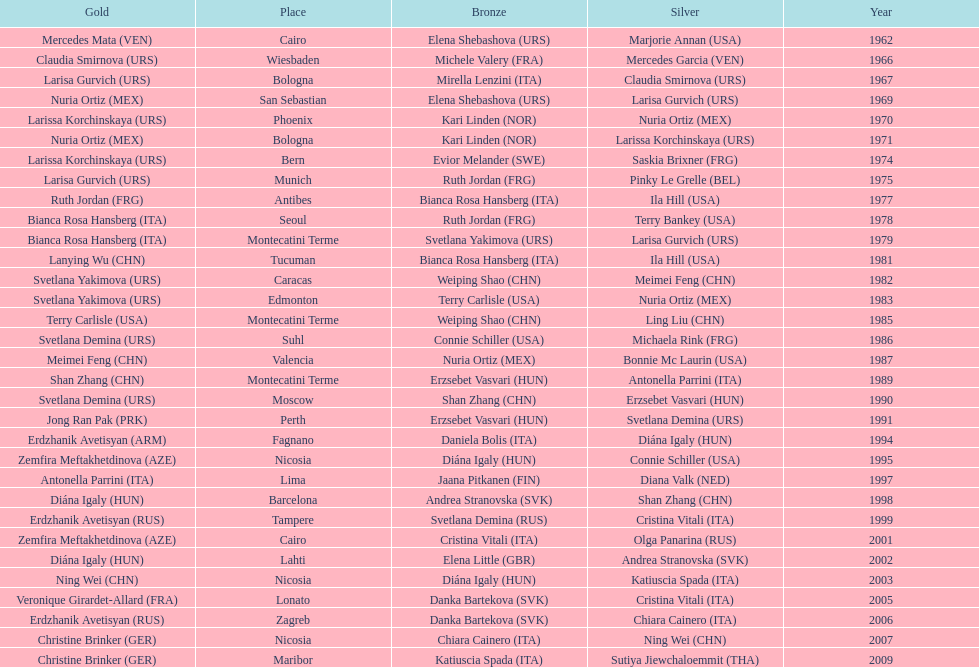What is the total of silver for cairo 0. 